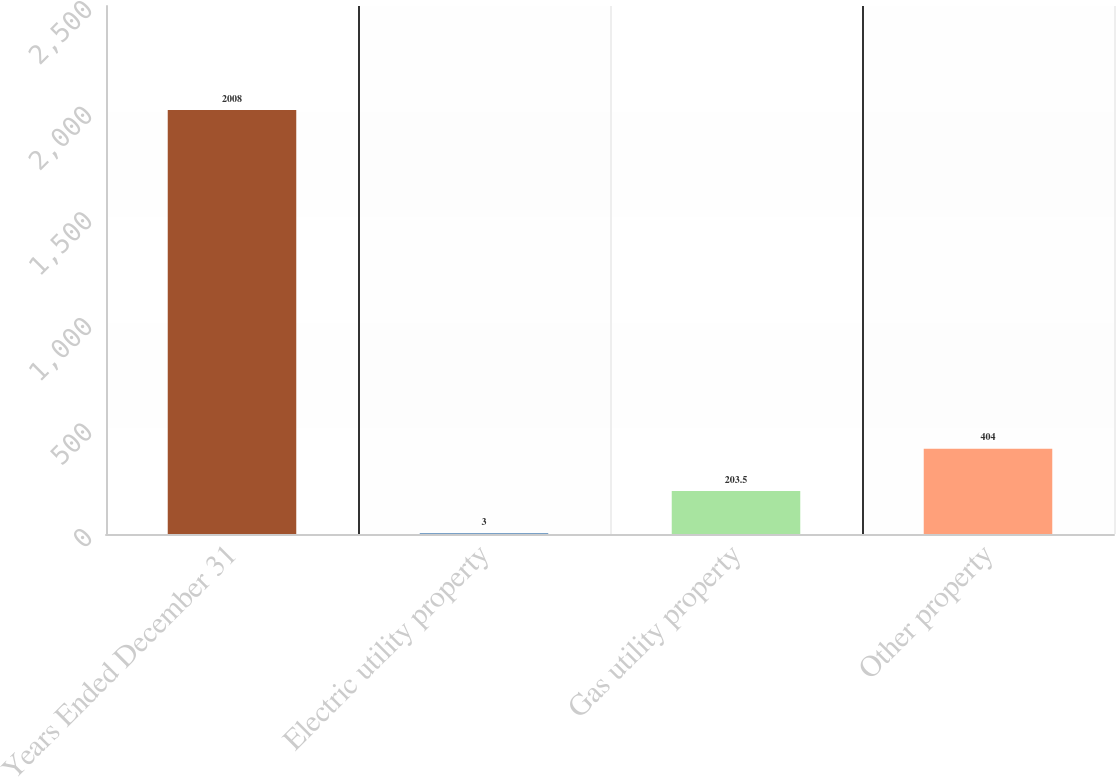Convert chart to OTSL. <chart><loc_0><loc_0><loc_500><loc_500><bar_chart><fcel>Years Ended December 31<fcel>Electric utility property<fcel>Gas utility property<fcel>Other property<nl><fcel>2008<fcel>3<fcel>203.5<fcel>404<nl></chart> 